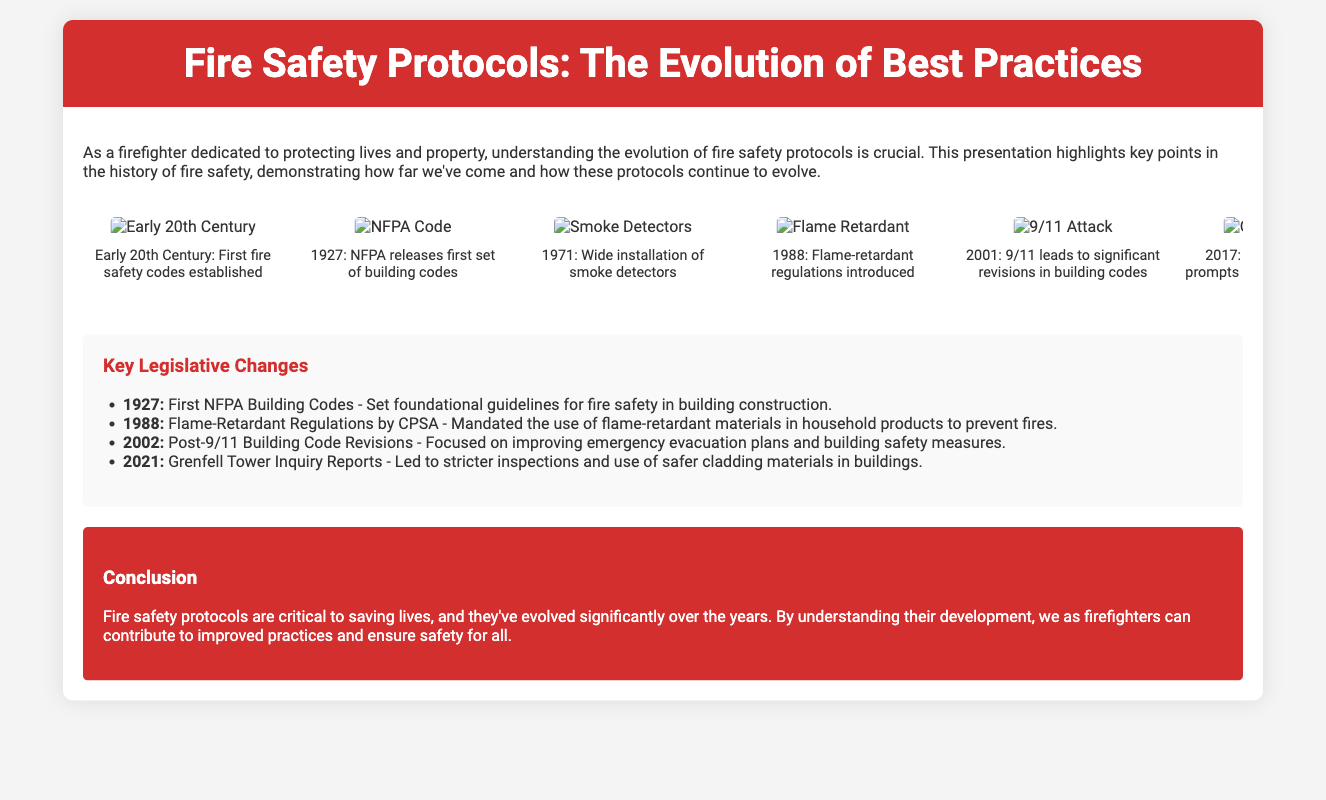what year were smoke detectors widely installed? The timeline specifies that smoke detectors were widely installed in the year 1971.
Answer: 1971 what significant event in 2001 led to revisions in building codes? The timeline notes that the 9/11 attack in 2001 resulted in significant building code revisions.
Answer: 9/11 attack what was introduced in 1988 regarding fire safety? The timeline mentions that flame-retardant regulations were introduced in 1988.
Answer: Flame-retardant regulations which landmark fire in 2017 prompted a global re-examination of fire safety? The timeline indicates that the Grenfell Tower fire in 2017 caused a global re-examination of fire safety protocols.
Answer: Grenfell Tower fire what foundational guidelines were established in 1927? The legislation section states that the first NFPA Building Codes set foundational guidelines for fire safety in construction.
Answer: First NFPA Building Codes what type of materials were mandated by regulations in 1988? The legislation mentions that flame-retardant materials were mandated in household products by CPSA in 1988.
Answer: Flame-retardant materials what is the main focus of the post-9/11 building code revisions in 2002? According to the legislation section, the focus was on improving emergency evacuation plans and building safety measures.
Answer: Improving emergency evacuation plans how many key legislative changes are mentioned in the document? The document lists a total of four key legislative changes in the legislation section.
Answer: Four what is the primary purpose of evolving fire safety protocols according to the conclusion? The conclusion states that the primary purpose of evolving fire safety protocols is to save lives.
Answer: To save lives 